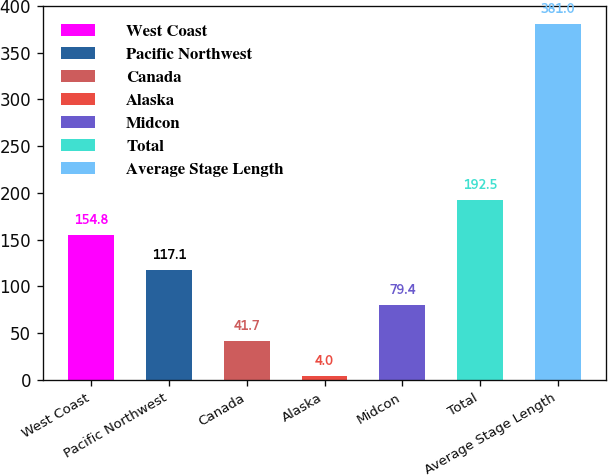Convert chart to OTSL. <chart><loc_0><loc_0><loc_500><loc_500><bar_chart><fcel>West Coast<fcel>Pacific Northwest<fcel>Canada<fcel>Alaska<fcel>Midcon<fcel>Total<fcel>Average Stage Length<nl><fcel>154.8<fcel>117.1<fcel>41.7<fcel>4<fcel>79.4<fcel>192.5<fcel>381<nl></chart> 